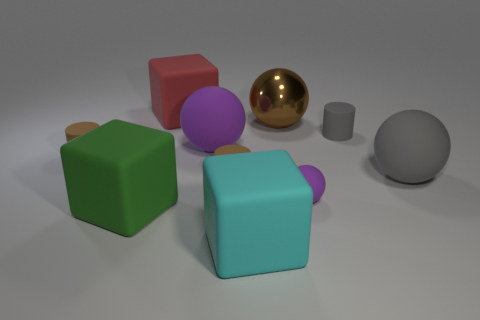Subtract all blocks. How many objects are left? 7 Subtract 1 gray cylinders. How many objects are left? 9 Subtract all tiny purple matte things. Subtract all cyan rubber blocks. How many objects are left? 8 Add 2 green rubber blocks. How many green rubber blocks are left? 3 Add 10 small yellow matte spheres. How many small yellow matte spheres exist? 10 